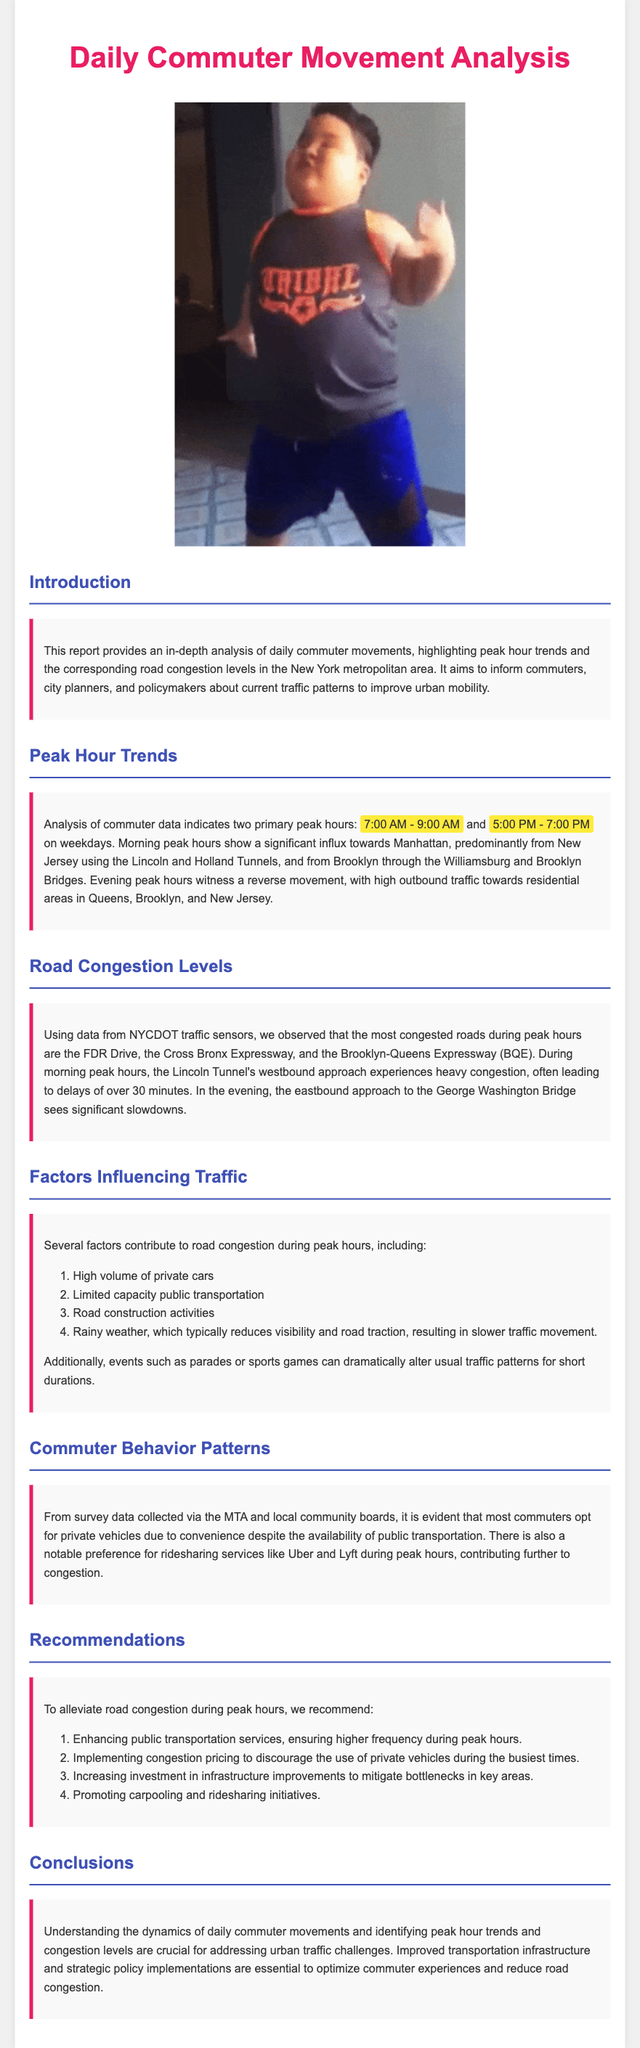What are the primary peak hours? The document states the primary peak hours for commuter movement, which are from 7:00 AM to 9:00 AM and from 5:00 PM to 7:00 PM.
Answer: 7:00 AM - 9:00 AM and 5:00 PM - 7:00 PM Which tunnel experiences heavy congestion during morning peak hours? The report mentions that during morning peak hours, the Lincoln Tunnel's westbound approach experiences heavy congestion.
Answer: Lincoln Tunnel What are the most congested roads mentioned in the report? The document lists the most congested roads during peak hours as the FDR Drive, Cross Bronx Expressway, and Brooklyn-Queens Expressway.
Answer: FDR Drive, Cross Bronx Expressway, Brooklyn-Queens Expressway What is one factor that influences road congestion? The report identifies several factors contributing to road congestion, one of which is the high volume of private cars.
Answer: High volume of private cars What is one recommendation provided to alleviate congestion? The document offers several recommendations, one of which is enhancing public transportation services during peak hours.
Answer: Enhancing public transportation services 